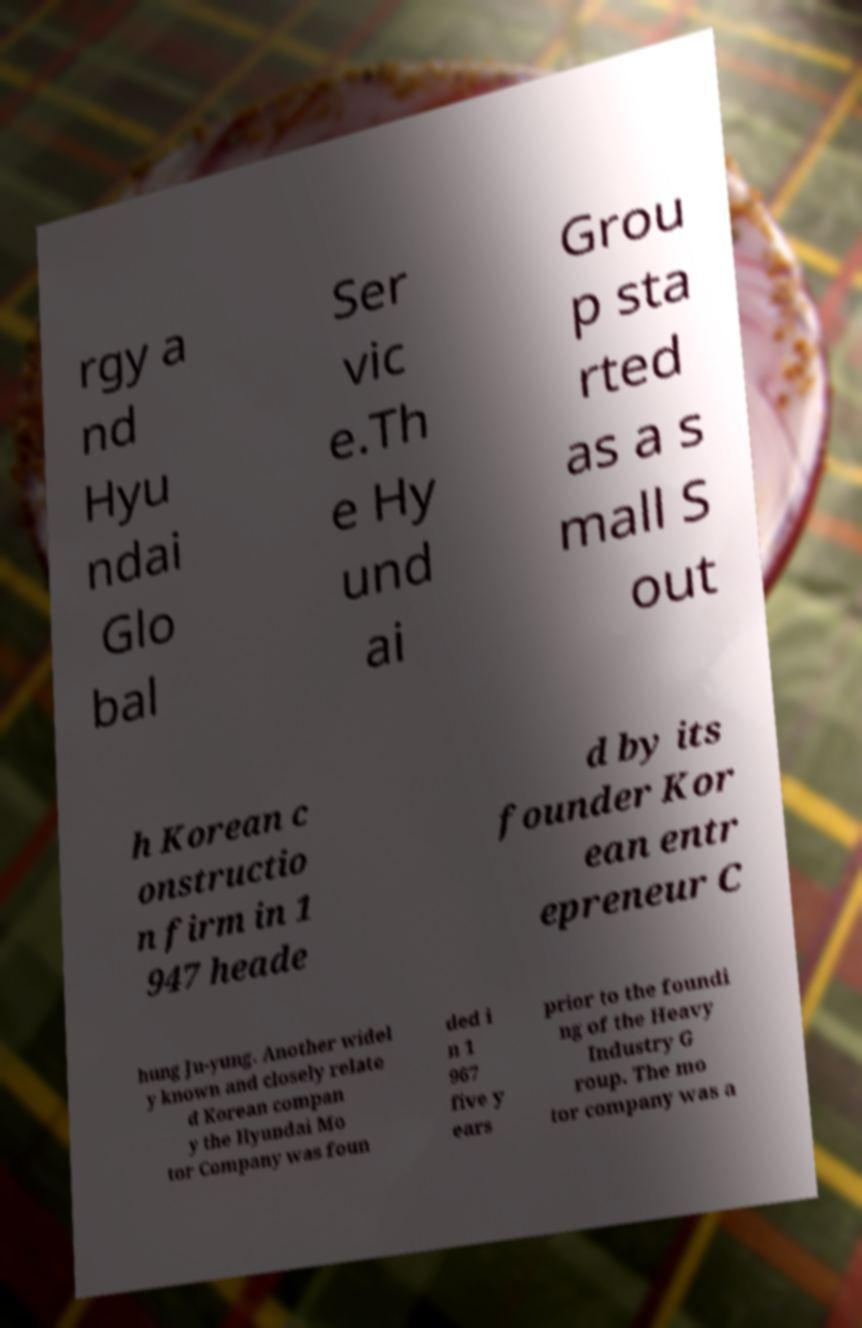Could you extract and type out the text from this image? rgy a nd Hyu ndai Glo bal Ser vic e.Th e Hy und ai Grou p sta rted as a s mall S out h Korean c onstructio n firm in 1 947 heade d by its founder Kor ean entr epreneur C hung Ju-yung. Another widel y known and closely relate d Korean compan y the Hyundai Mo tor Company was foun ded i n 1 967 five y ears prior to the foundi ng of the Heavy Industry G roup. The mo tor company was a 